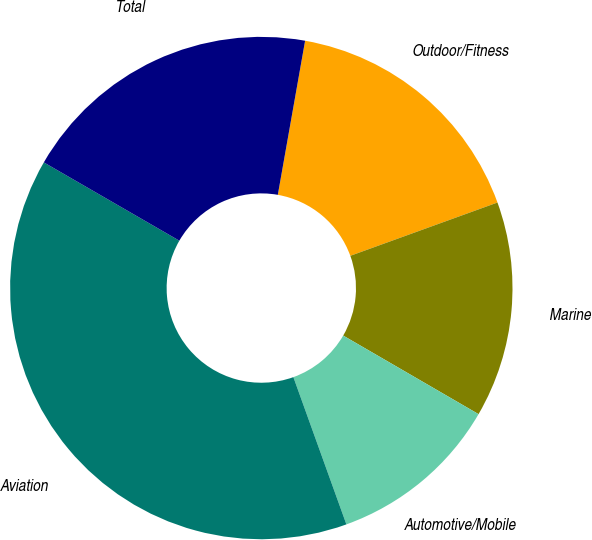Convert chart. <chart><loc_0><loc_0><loc_500><loc_500><pie_chart><fcel>Outdoor/Fitness<fcel>Marine<fcel>Automotive/Mobile<fcel>Aviation<fcel>Total<nl><fcel>16.68%<fcel>13.9%<fcel>11.13%<fcel>38.84%<fcel>19.45%<nl></chart> 